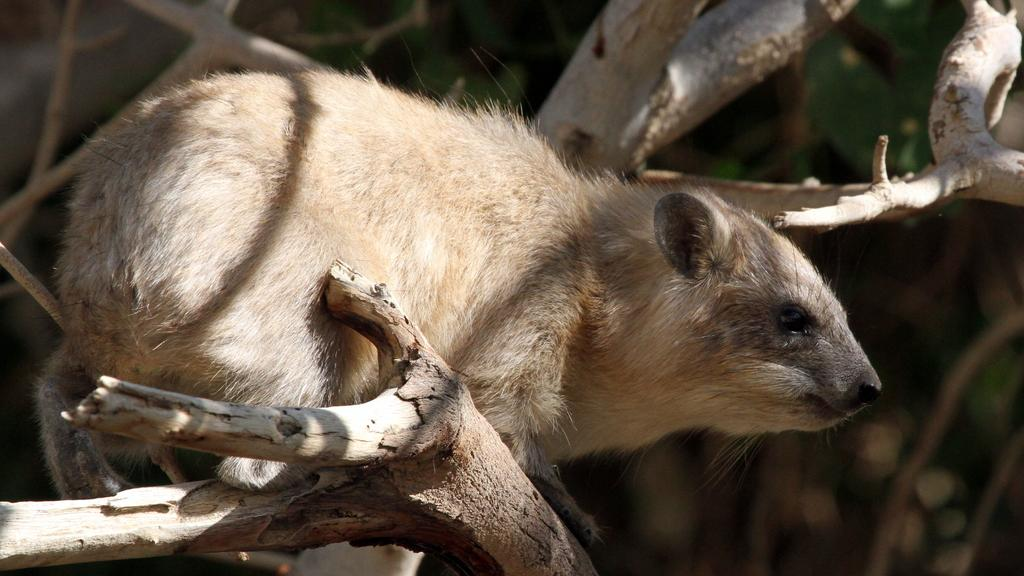What type of animal can be seen in the image? There is a brown color animal in the image. Where is the animal located? The animal is sitting on a tree. What type of paint is being used by the animal in the image? There is no paint or painting activity depicted in the image. The animal is simply sitting on a tree. 